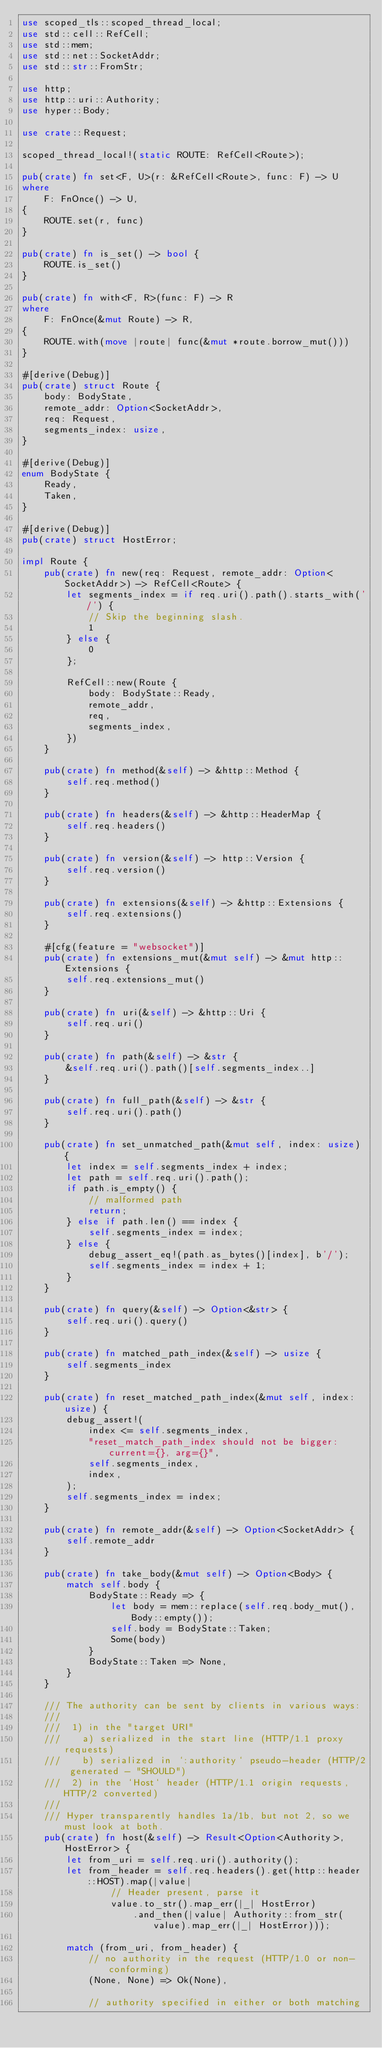Convert code to text. <code><loc_0><loc_0><loc_500><loc_500><_Rust_>use scoped_tls::scoped_thread_local;
use std::cell::RefCell;
use std::mem;
use std::net::SocketAddr;
use std::str::FromStr;

use http;
use http::uri::Authority;
use hyper::Body;

use crate::Request;

scoped_thread_local!(static ROUTE: RefCell<Route>);

pub(crate) fn set<F, U>(r: &RefCell<Route>, func: F) -> U
where
    F: FnOnce() -> U,
{
    ROUTE.set(r, func)
}

pub(crate) fn is_set() -> bool {
    ROUTE.is_set()
}

pub(crate) fn with<F, R>(func: F) -> R
where
    F: FnOnce(&mut Route) -> R,
{
    ROUTE.with(move |route| func(&mut *route.borrow_mut()))
}

#[derive(Debug)]
pub(crate) struct Route {
    body: BodyState,
    remote_addr: Option<SocketAddr>,
    req: Request,
    segments_index: usize,
}

#[derive(Debug)]
enum BodyState {
    Ready,
    Taken,
}

#[derive(Debug)]
pub(crate) struct HostError;

impl Route {
    pub(crate) fn new(req: Request, remote_addr: Option<SocketAddr>) -> RefCell<Route> {
        let segments_index = if req.uri().path().starts_with('/') {
            // Skip the beginning slash.
            1
        } else {
            0
        };

        RefCell::new(Route {
            body: BodyState::Ready,
            remote_addr,
            req,
            segments_index,
        })
    }

    pub(crate) fn method(&self) -> &http::Method {
        self.req.method()
    }

    pub(crate) fn headers(&self) -> &http::HeaderMap {
        self.req.headers()
    }

    pub(crate) fn version(&self) -> http::Version {
        self.req.version()
    }

    pub(crate) fn extensions(&self) -> &http::Extensions {
        self.req.extensions()
    }

    #[cfg(feature = "websocket")]
    pub(crate) fn extensions_mut(&mut self) -> &mut http::Extensions {
        self.req.extensions_mut()
    }

    pub(crate) fn uri(&self) -> &http::Uri {
        self.req.uri()
    }

    pub(crate) fn path(&self) -> &str {
        &self.req.uri().path()[self.segments_index..]
    }

    pub(crate) fn full_path(&self) -> &str {
        self.req.uri().path()
    }

    pub(crate) fn set_unmatched_path(&mut self, index: usize) {
        let index = self.segments_index + index;
        let path = self.req.uri().path();
        if path.is_empty() {
            // malformed path
            return;
        } else if path.len() == index {
            self.segments_index = index;
        } else {
            debug_assert_eq!(path.as_bytes()[index], b'/');
            self.segments_index = index + 1;
        }
    }

    pub(crate) fn query(&self) -> Option<&str> {
        self.req.uri().query()
    }

    pub(crate) fn matched_path_index(&self) -> usize {
        self.segments_index
    }

    pub(crate) fn reset_matched_path_index(&mut self, index: usize) {
        debug_assert!(
            index <= self.segments_index,
            "reset_match_path_index should not be bigger: current={}, arg={}",
            self.segments_index,
            index,
        );
        self.segments_index = index;
    }

    pub(crate) fn remote_addr(&self) -> Option<SocketAddr> {
        self.remote_addr
    }

    pub(crate) fn take_body(&mut self) -> Option<Body> {
        match self.body {
            BodyState::Ready => {
                let body = mem::replace(self.req.body_mut(), Body::empty());
                self.body = BodyState::Taken;
                Some(body)
            }
            BodyState::Taken => None,
        }
    }

    /// The authority can be sent by clients in various ways:
    ///
    ///  1) in the "target URI"
    ///    a) serialized in the start line (HTTP/1.1 proxy requests)
    ///    b) serialized in `:authority` pseudo-header (HTTP/2 generated - "SHOULD")
    ///  2) in the `Host` header (HTTP/1.1 origin requests, HTTP/2 converted)
    ///
    /// Hyper transparently handles 1a/1b, but not 2, so we must look at both.
    pub(crate) fn host(&self) -> Result<Option<Authority>, HostError> {
        let from_uri = self.req.uri().authority();
        let from_header = self.req.headers().get(http::header::HOST).map(|value|
                // Header present, parse it
                value.to_str().map_err(|_| HostError)
                    .and_then(|value| Authority::from_str(value).map_err(|_| HostError)));

        match (from_uri, from_header) {
            // no authority in the request (HTTP/1.0 or non-conforming)
            (None, None) => Ok(None),

            // authority specified in either or both matching</code> 